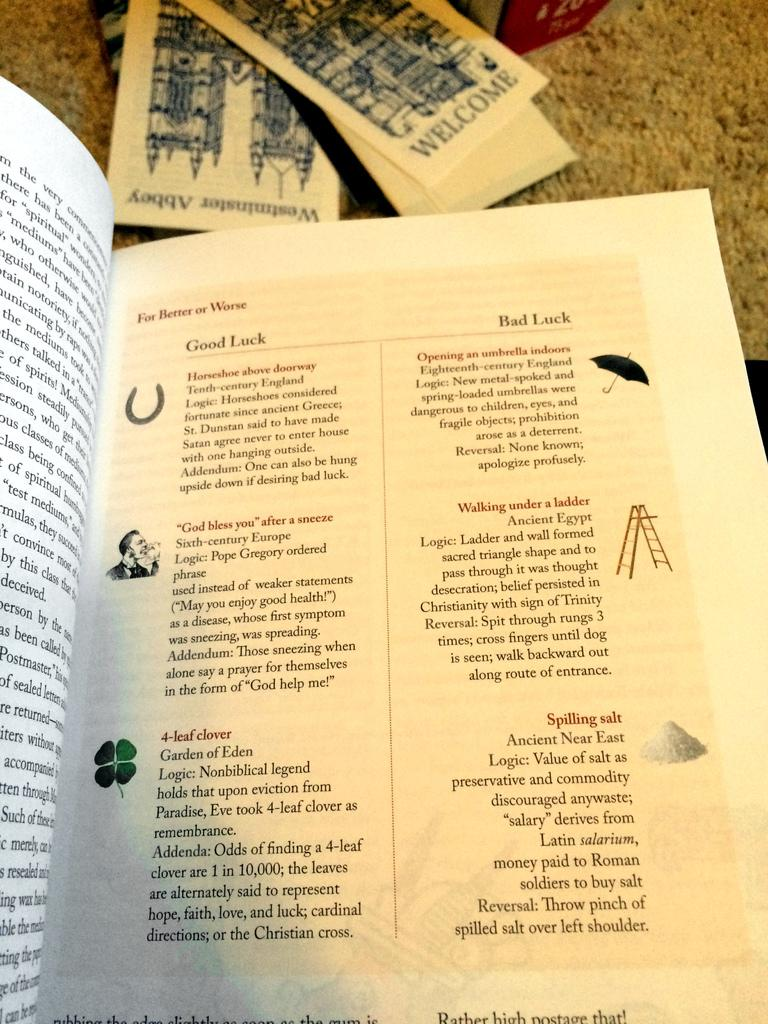<image>
Render a clear and concise summary of the photo. An opened book to a page about, For Better or Worse, sitting on the carpet next to some pamphlets. 